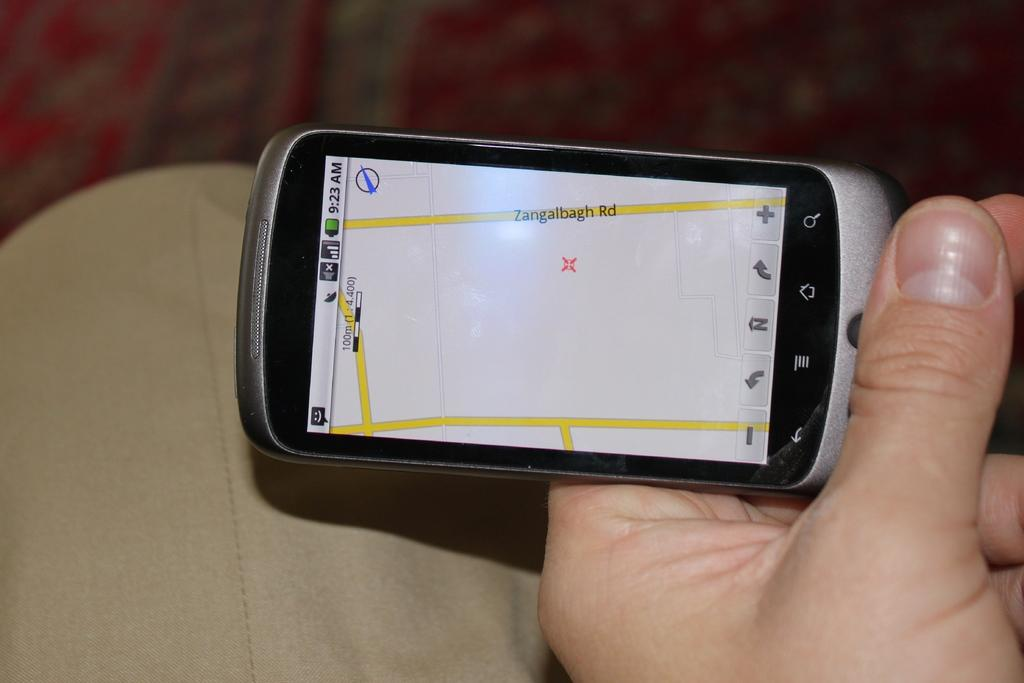<image>
Give a short and clear explanation of the subsequent image. A navigation system is showing a street called Zangalbagh Rd. 